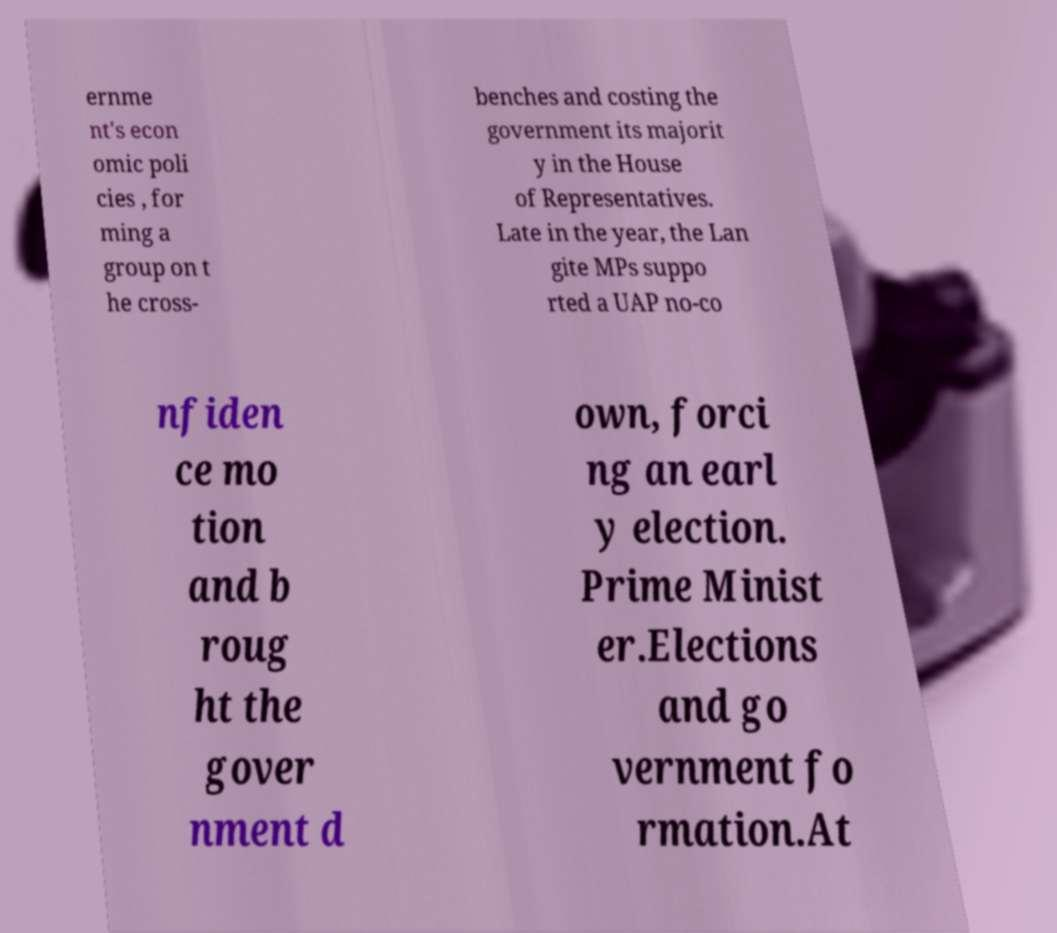Please read and relay the text visible in this image. What does it say? ernme nt's econ omic poli cies , for ming a group on t he cross- benches and costing the government its majorit y in the House of Representatives. Late in the year, the Lan gite MPs suppo rted a UAP no-co nfiden ce mo tion and b roug ht the gover nment d own, forci ng an earl y election. Prime Minist er.Elections and go vernment fo rmation.At 